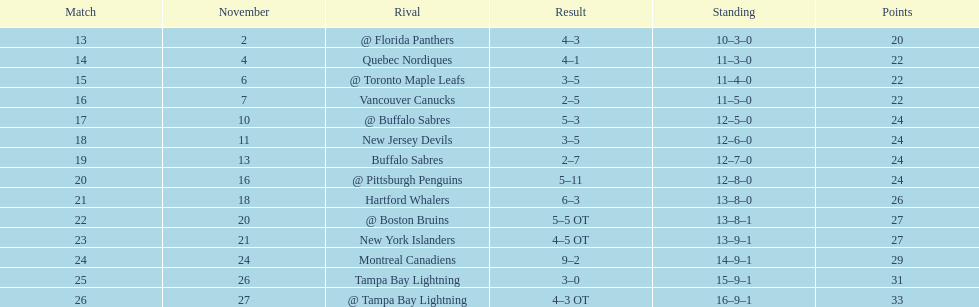Did the tampa bay lightning have the least amount of wins? Yes. 